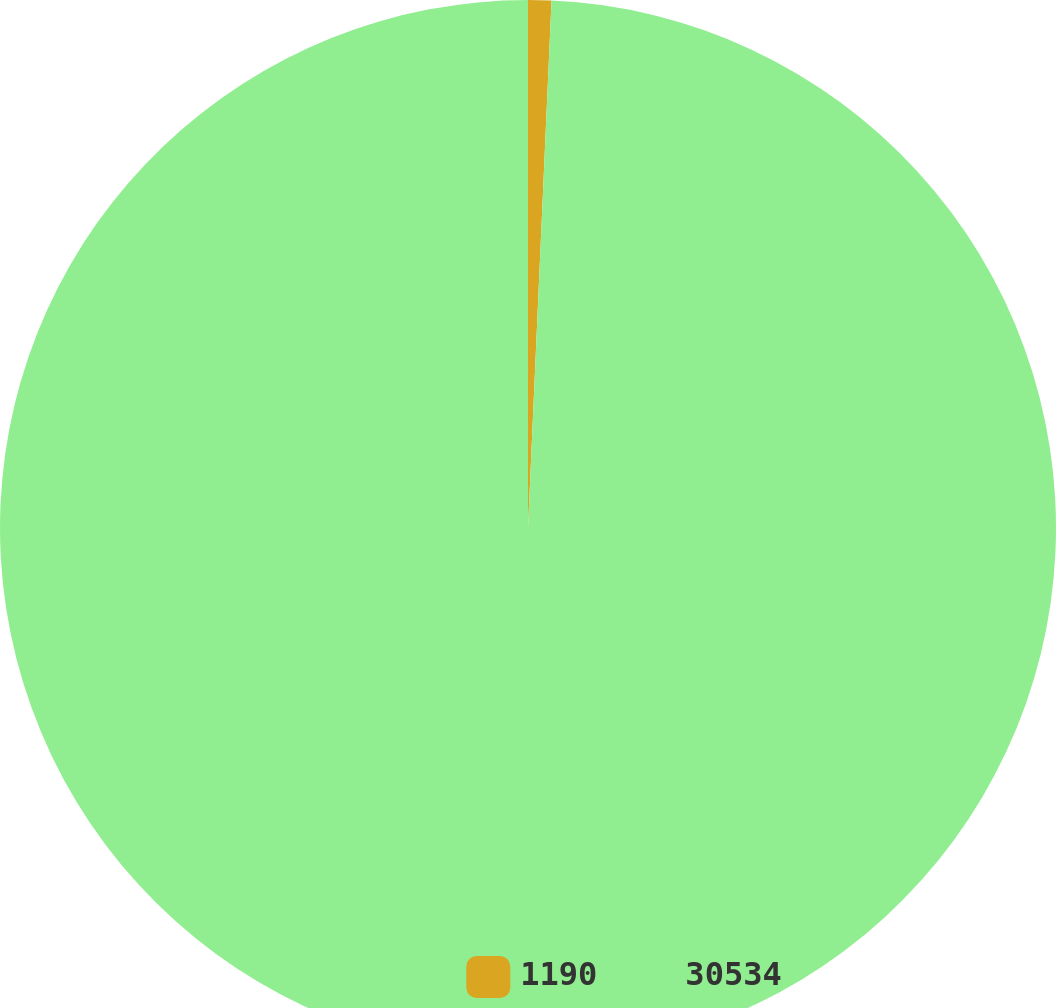Convert chart. <chart><loc_0><loc_0><loc_500><loc_500><pie_chart><fcel>1190<fcel>30534<nl><fcel>0.71%<fcel>99.29%<nl></chart> 